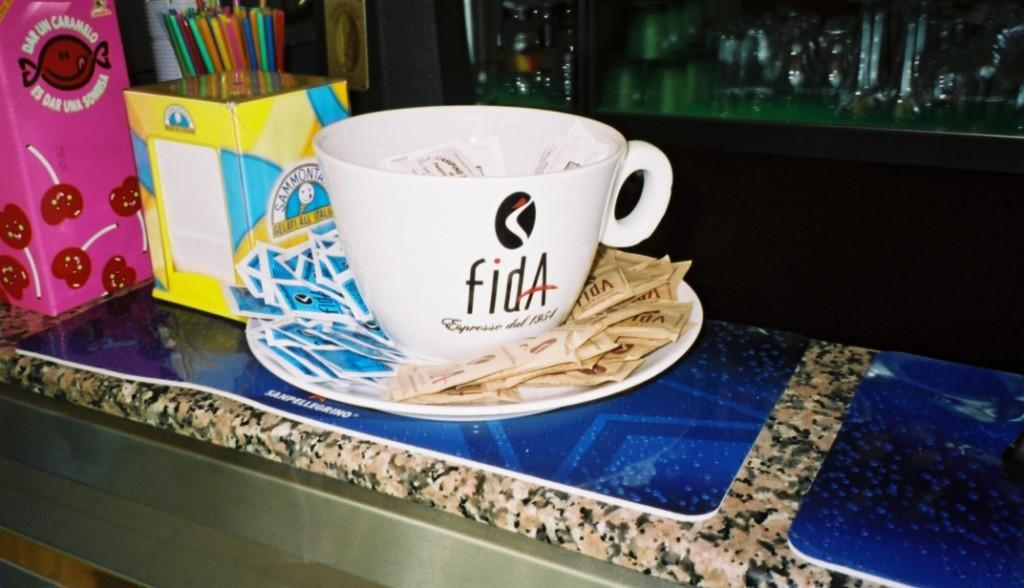What is located at the bottom of the image? There is a table at the bottom of the image. What items can be seen on the table? A cup and saucer, sachets, a box, and color pencils are on the table. Are there any other objects visible in the image? Bottles are visible in the background of the image. Where was the image taken? The image was taken inside a room. What type of canvas is being used to create a harmonious atmosphere in the image? There is no canvas or reference to harmony in the image; it features a table with various objects and a background with bottles. 